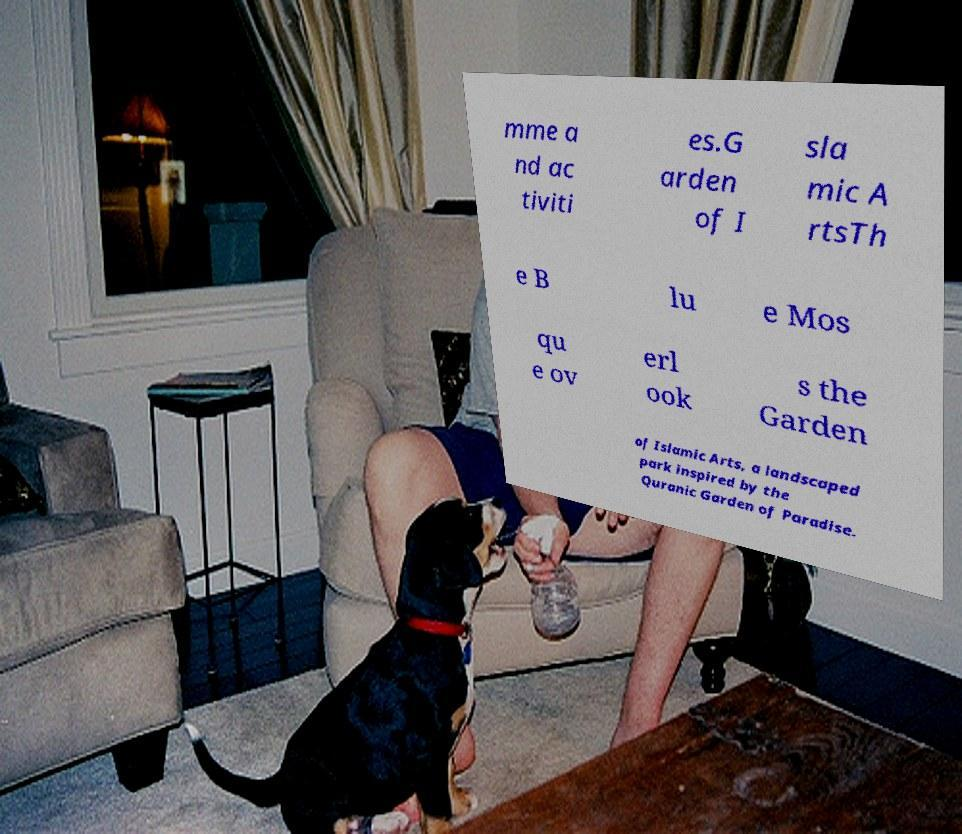Please identify and transcribe the text found in this image. mme a nd ac tiviti es.G arden of I sla mic A rtsTh e B lu e Mos qu e ov erl ook s the Garden of Islamic Arts, a landscaped park inspired by the Quranic Garden of Paradise. 